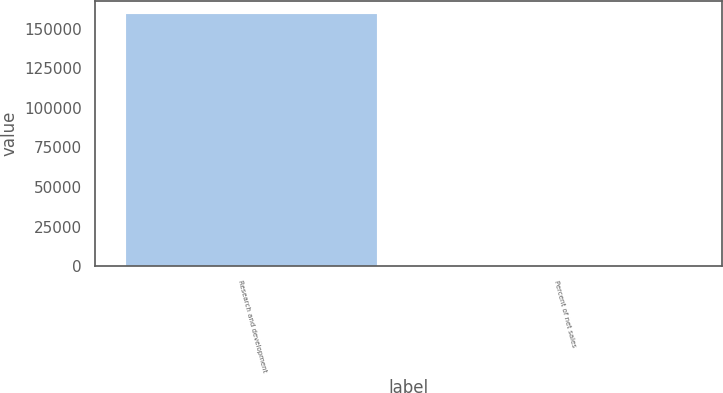Convert chart. <chart><loc_0><loc_0><loc_500><loc_500><bar_chart><fcel>Research and development<fcel>Percent of net sales<nl><fcel>159406<fcel>5<nl></chart> 